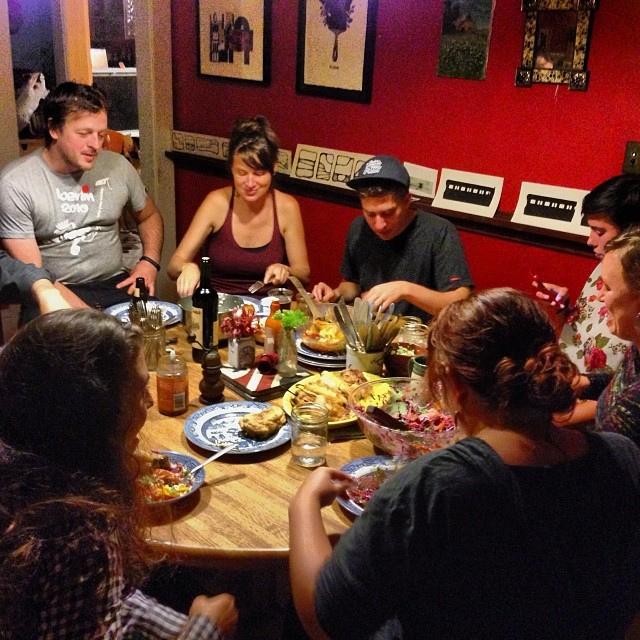How many bottles of wine do they have?
Keep it brief. 1. Who is wearing a maroon tank top?
Quick response, please. Woman. Are they having dinner?
Write a very short answer. Yes. 